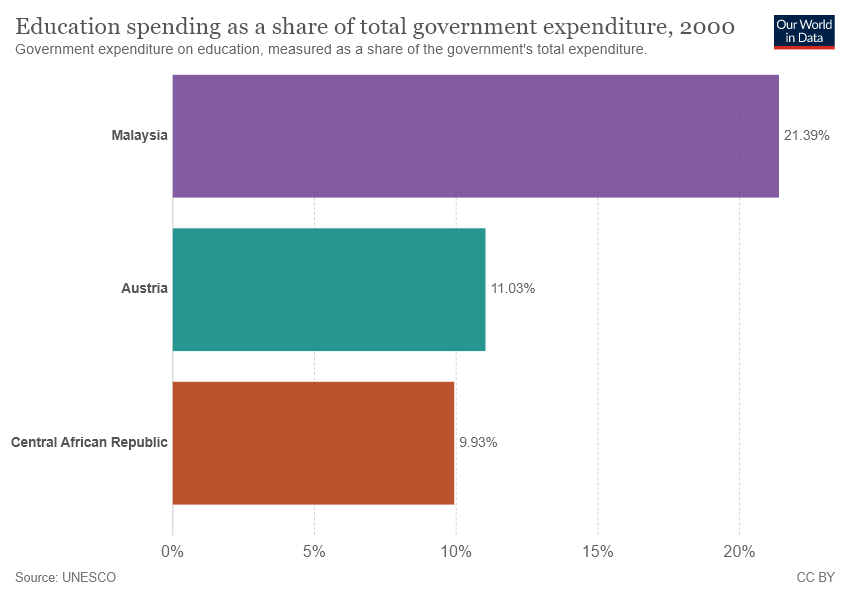Highlight a few significant elements in this photo. The average rate of education spending in Malaysia and Austria is 0.1621. Central African Republic is represented by the brown color bar. 